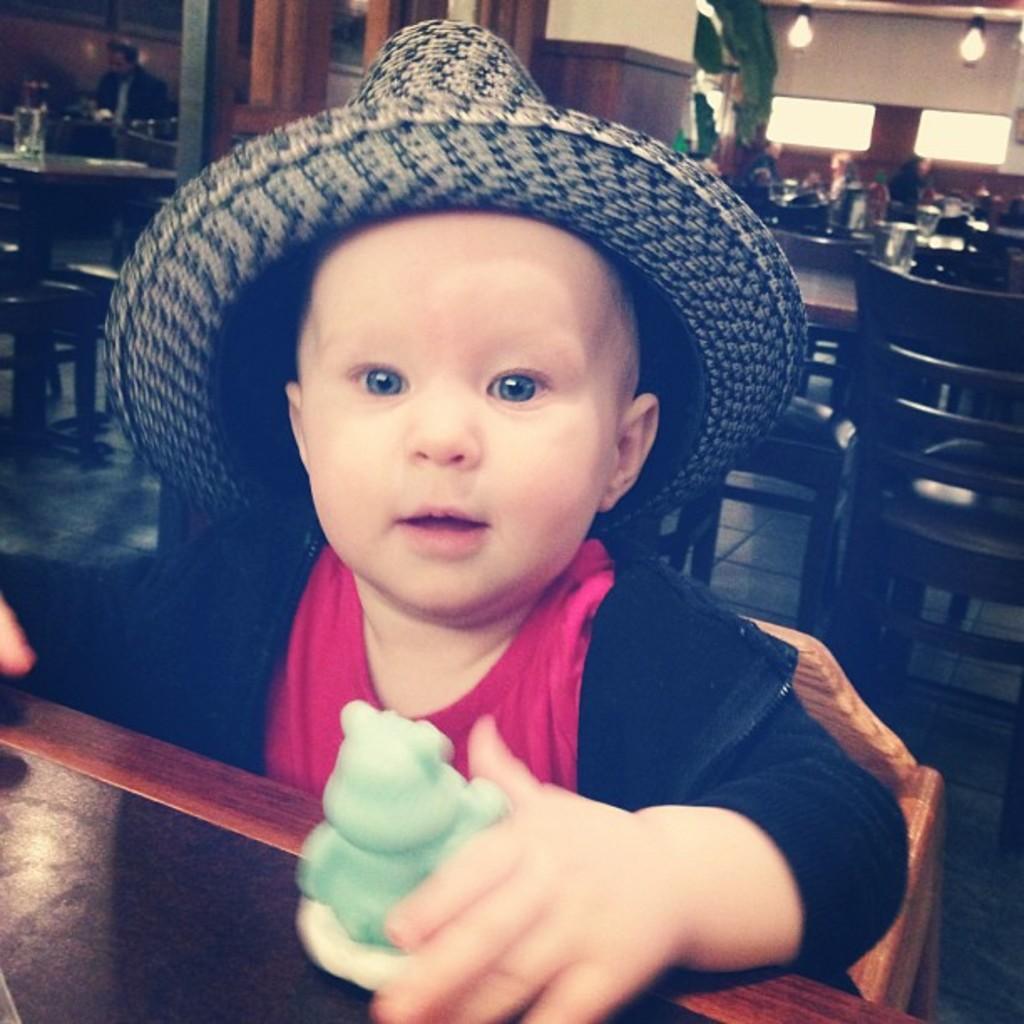In one or two sentences, can you explain what this image depicts? In the center of the image we can see baby sitting on the chair at the table. In the background we can see tables, chairs, persons, pillar, windows and wall. 